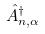<formula> <loc_0><loc_0><loc_500><loc_500>\hat { A } _ { n , \alpha } ^ { \dagger }</formula> 